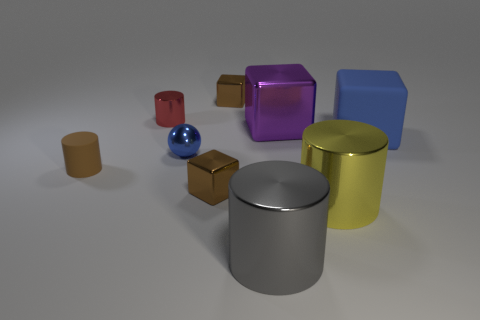Subtract all spheres. How many objects are left? 8 Add 2 tiny green metal blocks. How many tiny green metal blocks exist? 2 Subtract 0 purple spheres. How many objects are left? 9 Subtract all small cyan metallic cylinders. Subtract all small brown rubber cylinders. How many objects are left? 8 Add 6 large purple objects. How many large purple objects are left? 7 